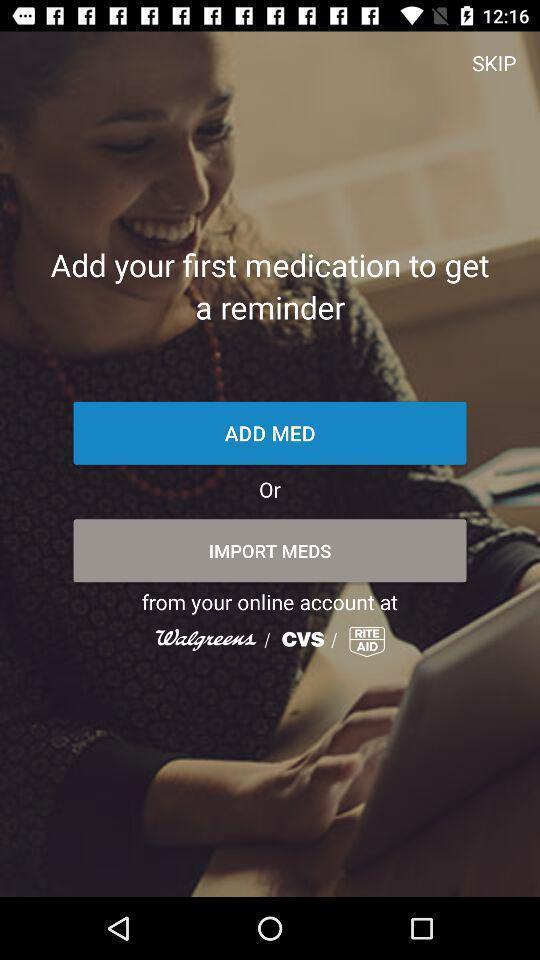Provide a textual representation of this image. Screen shows a login page. 